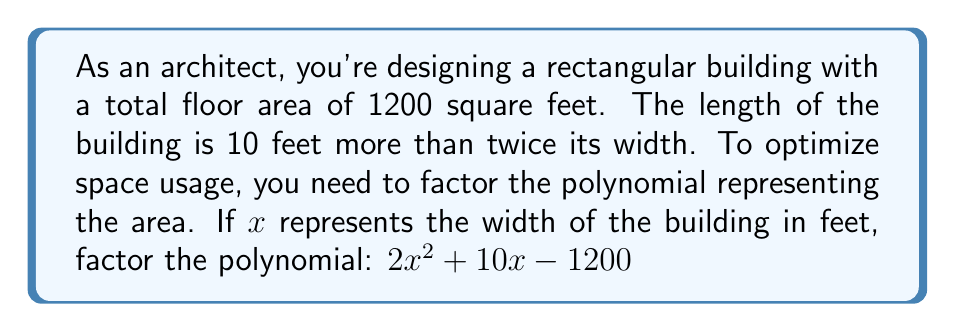Can you solve this math problem? Let's approach this step-by-step:

1) The polynomial we need to factor is $2x^2 + 10x - 1200$

2) This is a quadratic equation in the form $ax^2 + bx + c$, where:
   $a = 2$, $b = 10$, and $c = -1200$

3) To factor this, we'll use the ac-method:
   - Multiply $a * c = 2 * (-1200) = -2400$
   - Find two numbers that multiply to give -2400 and add up to $b = 10$
   - These numbers are 50 and -40

4) Rewrite the middle term using these numbers:
   $2x^2 + 50x - 40x - 1200$

5) Group the terms:
   $(2x^2 + 50x) + (-40x - 1200)$

6) Factor out the common factors from each group:
   $2x(x + 25) - 40(x + 30)$

7) Factor out the common binomial:
   $(x + 30)(2x - 40)$

8) This can be further simplified to:
   $(x + 30)(2(x - 20))$

Therefore, the factored form of $2x^2 + 10x - 1200$ is $(x + 30)(2(x - 20))$

In architectural terms, this means the width of the building ($x$) plus 30 feet, multiplied by twice the width minus 40 feet, equals the total area.
Answer: $(x + 30)(2(x - 20))$ 